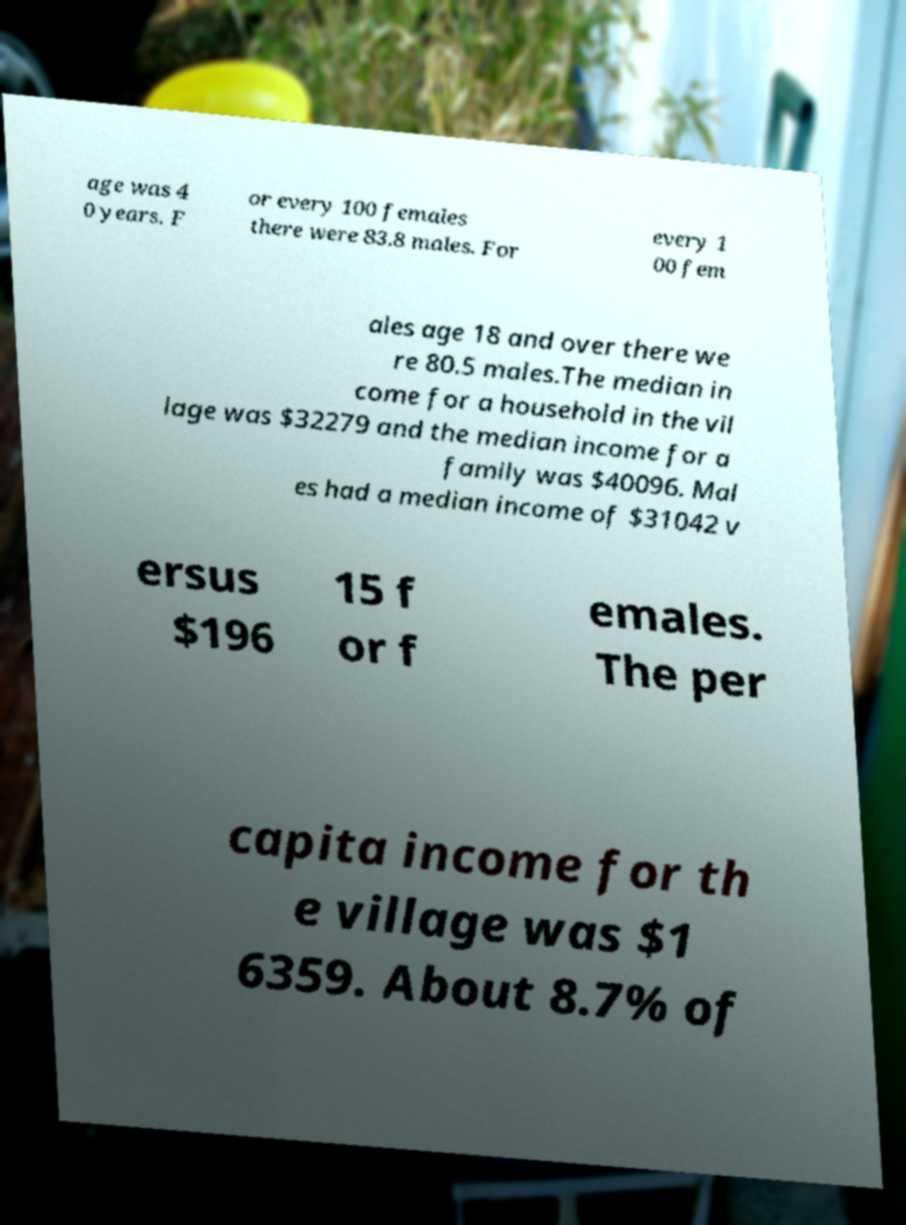Can you read and provide the text displayed in the image?This photo seems to have some interesting text. Can you extract and type it out for me? age was 4 0 years. F or every 100 females there were 83.8 males. For every 1 00 fem ales age 18 and over there we re 80.5 males.The median in come for a household in the vil lage was $32279 and the median income for a family was $40096. Mal es had a median income of $31042 v ersus $196 15 f or f emales. The per capita income for th e village was $1 6359. About 8.7% of 